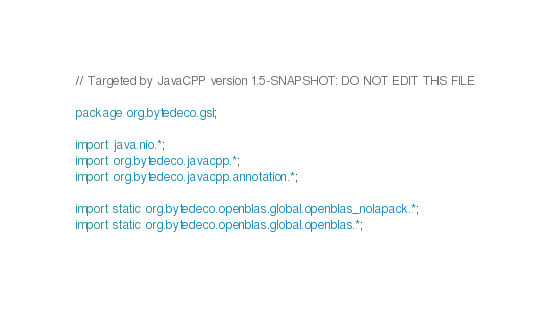<code> <loc_0><loc_0><loc_500><loc_500><_Java_>// Targeted by JavaCPP version 1.5-SNAPSHOT: DO NOT EDIT THIS FILE

package org.bytedeco.gsl;

import java.nio.*;
import org.bytedeco.javacpp.*;
import org.bytedeco.javacpp.annotation.*;

import static org.bytedeco.openblas.global.openblas_nolapack.*;
import static org.bytedeco.openblas.global.openblas.*;
</code> 